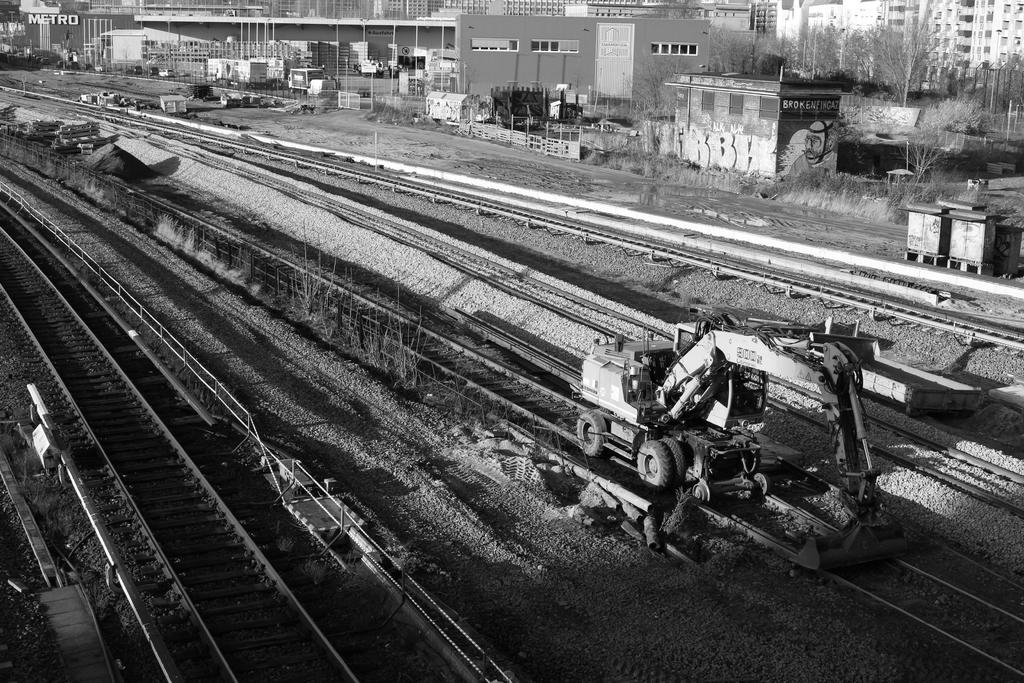What can be seen running through the image? There are tracks in the image. What is on the tracks in the image? A vehicle is present on the tracks. What type of vegetation is visible to the right of the tracks? There are many trees to the right of the tracks. What type of structures can be seen in the image? There are sheds and buildings in the image. What else can be seen in the image besides the tracks and structures? There are containers visible in the image. Can you see a lock on the vehicle in the image? There is no lock visible on the vehicle in the image. What type of animal can be seen slithering through the trees in the image? There are no animals, including snakes, present in the image. 